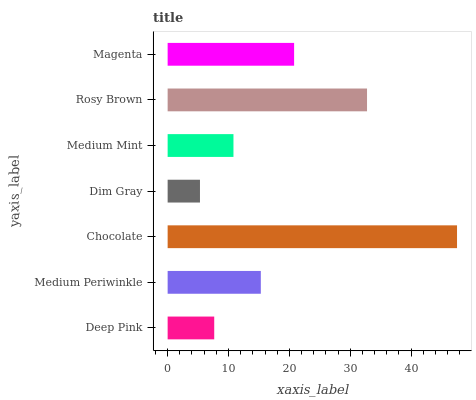Is Dim Gray the minimum?
Answer yes or no. Yes. Is Chocolate the maximum?
Answer yes or no. Yes. Is Medium Periwinkle the minimum?
Answer yes or no. No. Is Medium Periwinkle the maximum?
Answer yes or no. No. Is Medium Periwinkle greater than Deep Pink?
Answer yes or no. Yes. Is Deep Pink less than Medium Periwinkle?
Answer yes or no. Yes. Is Deep Pink greater than Medium Periwinkle?
Answer yes or no. No. Is Medium Periwinkle less than Deep Pink?
Answer yes or no. No. Is Medium Periwinkle the high median?
Answer yes or no. Yes. Is Medium Periwinkle the low median?
Answer yes or no. Yes. Is Deep Pink the high median?
Answer yes or no. No. Is Medium Mint the low median?
Answer yes or no. No. 